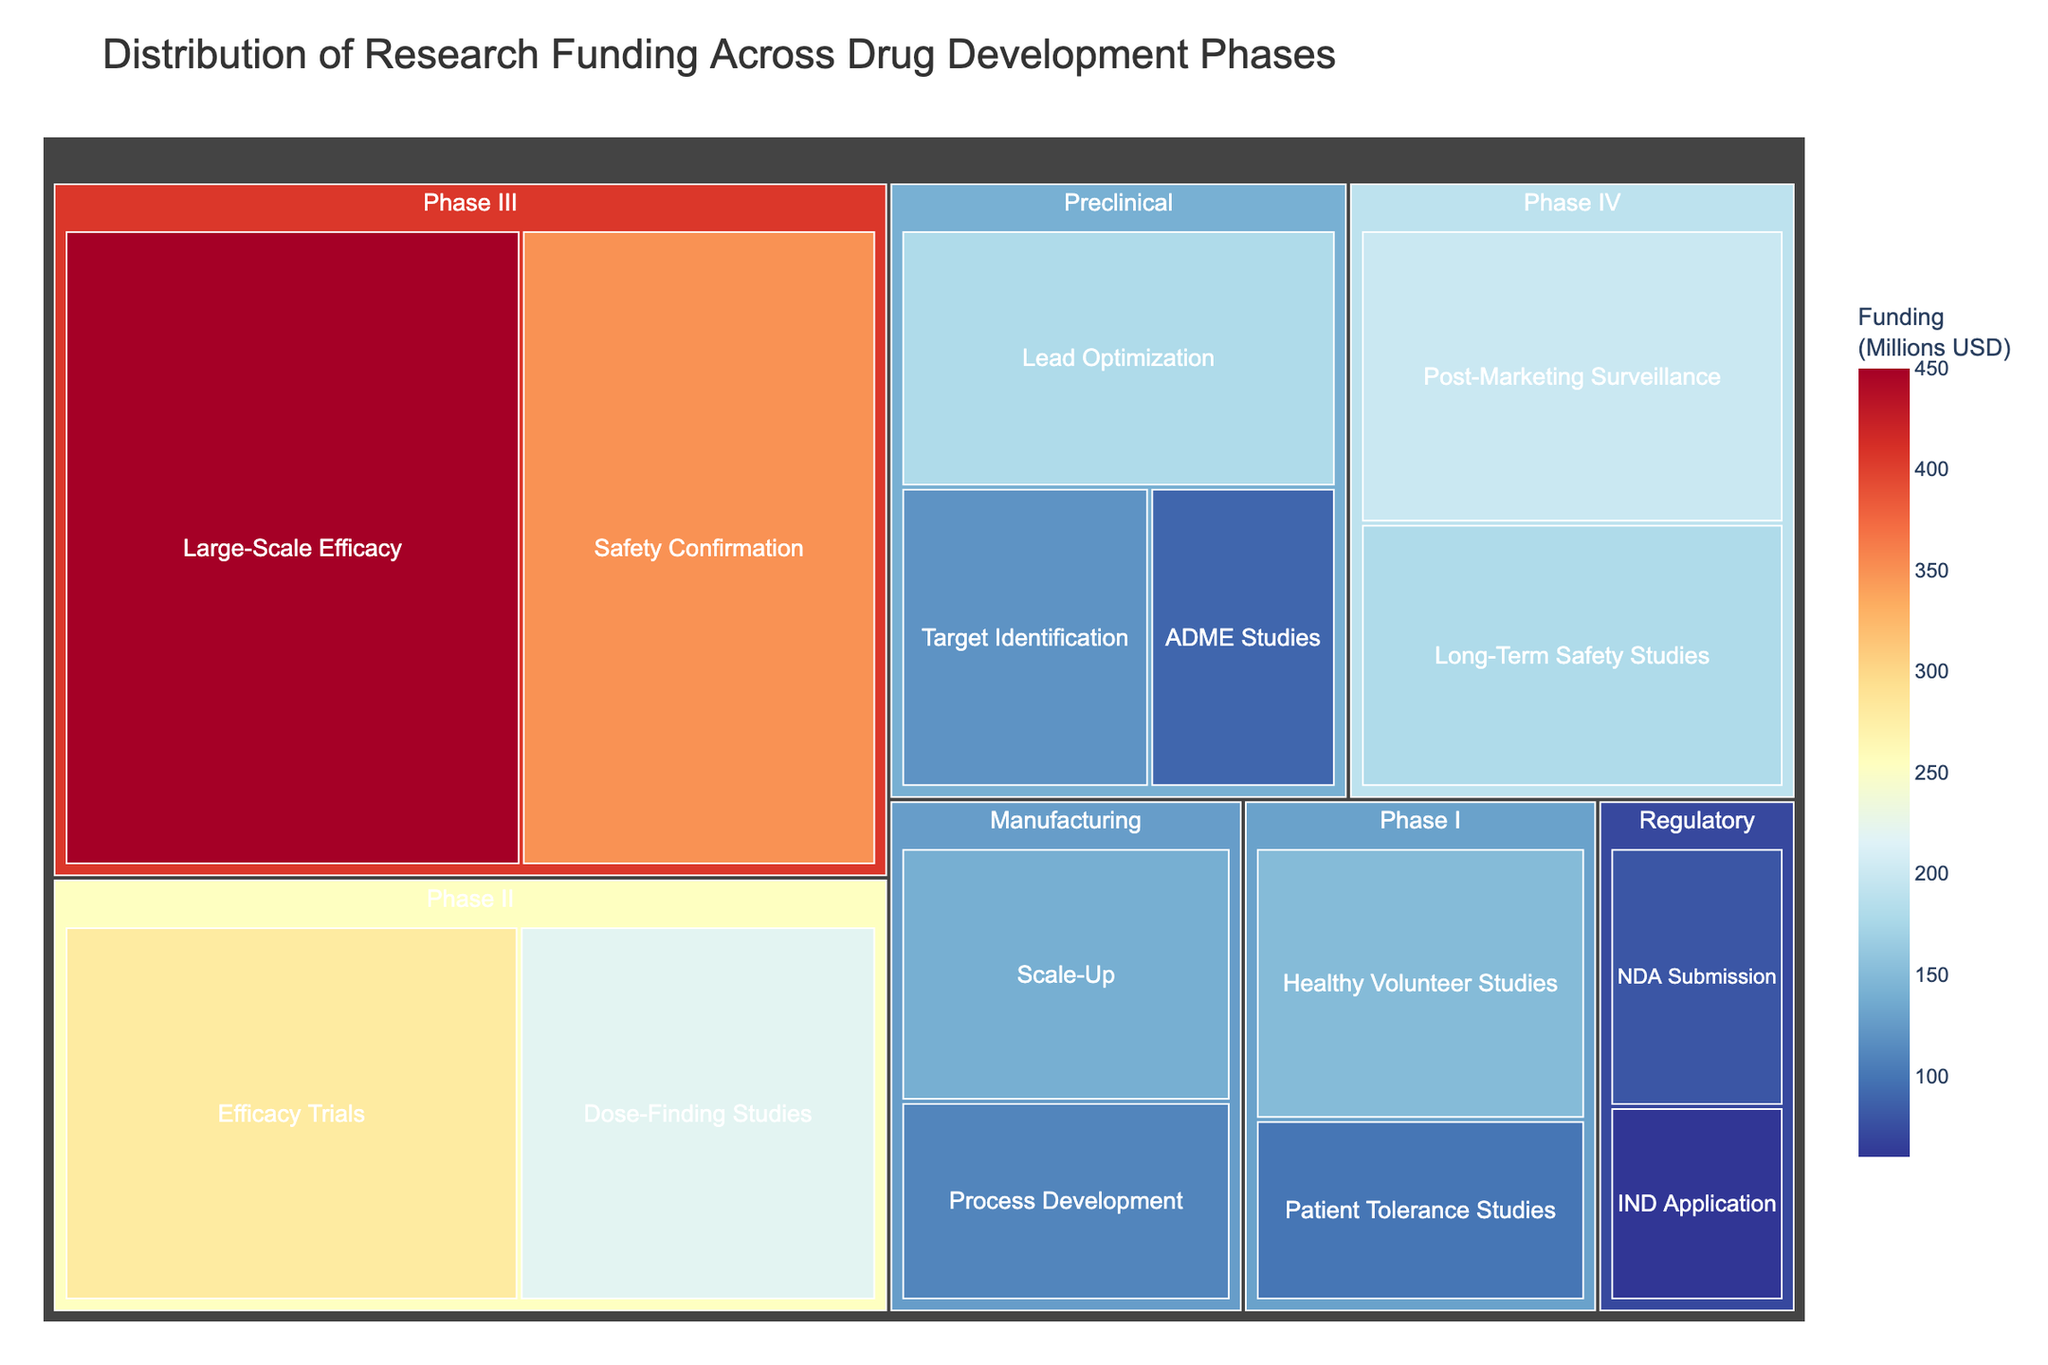What is the total funding for the Preclinical phase? Add the funding for all stages within the Preclinical phase: Target Identification (120), Lead Optimization (180), and ADME Studies (90). The total funding is 120 + 180 + 90 = 390 million USD.
Answer: 390 million USD Which phase has the highest funding in the entire drug development process? Compare the total funding of each phase. The Phase III has the highest funding with Large-Scale Efficacy (450) and Safety Confirmation (350) totaling 800 million USD.
Answer: Phase III What is the funding difference between Phase I and Phase II? Calculate the total funding for Phase I (Healthy Volunteer Studies: 150, Patient Tolerance Studies: 100) which is 150 + 100 = 250 million USD and for Phase II (Efficacy Trials: 280, Dose-Finding Studies: 220) which is 280 + 220 = 500 million USD. The difference is 500 - 250 = 250 million USD.
Answer: 250 million USD Which stage has the lowest funding and how much is it? Compare the funding of each stage and identify the lowest. The IND Application stage in the Regulatory phase has the lowest funding with 60 million USD.
Answer: IND Application, 60 million USD How much more funding does Phase III receive compared to Preclinical? Calculate total funding for Phase III and Preclinical. Phase III: 450 + 350 = 800 million USD. Preclinical: 120 + 180 + 90 = 390 million USD. The difference is 800 - 390 = 410 million USD.
Answer: 410 million USD What is the average funding for all stages under the Manufacturing phase? Sum the funding for the stages under Manufacturing (Process Development: 110, Scale-Up: 140) and divide by the number of stages. (110 + 140) / 2 = 125 million USD.
Answer: 125 million USD How does the funding for Post-Marketing Surveillance compare to Efficacy Trials in Phase II? Compare the funding amounts directly. Post-Marketing Surveillance (200 million USD) has less funding than Efficacy Trials (280 million USD).
Answer: Post-Marketing Surveillance has less funding What percentage of the total Phase IV funding is allocated to Long-Term Safety Studies? Calculate the total funding for Phase IV (Post-Marketing Surveillance: 200, Long-Term Safety Studies: 180) which is 200 + 180 = 380 million USD. Find the percentage (180 / 380) * 100 ≈ 47.37%.
Answer: Approximately 47.37% Which phase contains the stage with the highest individual funding amount and what is that amount? Identify the stage with the highest individual funding (Large-Scale Efficacy in Phase III with 450 million USD).
Answer: Phase III, 450 million USD If the total funding for drug development were to increase by 15%, which stage would receive the highest absolute increase in funding? Calculate the increased amount for each stage by multiplying the current funding by 0.15. The stage with the highest current funding, Large-Scale Efficacy (450 million USD), will receive the highest increase: 450 * 0.15 = 67.5 million USD.
Answer: Large-Scale Efficacy, 67.5 million USD 